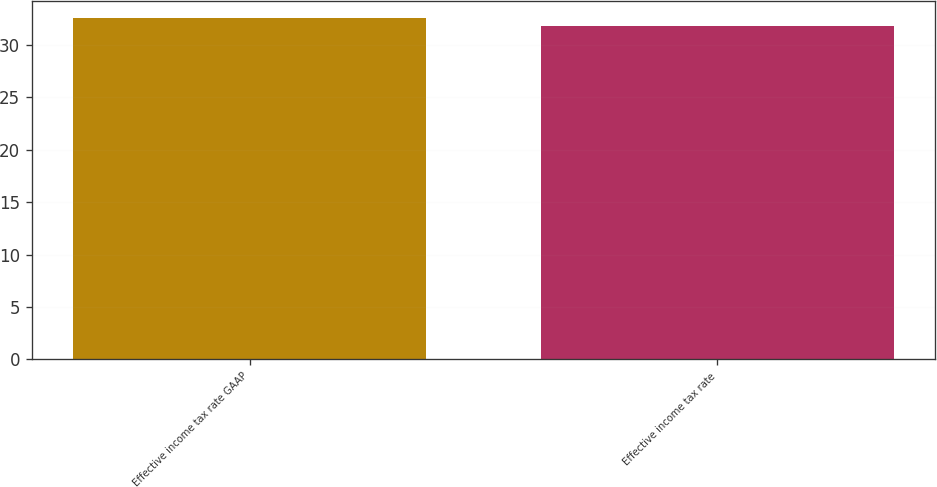<chart> <loc_0><loc_0><loc_500><loc_500><bar_chart><fcel>Effective income tax rate GAAP<fcel>Effective income tax rate<nl><fcel>32.6<fcel>31.8<nl></chart> 